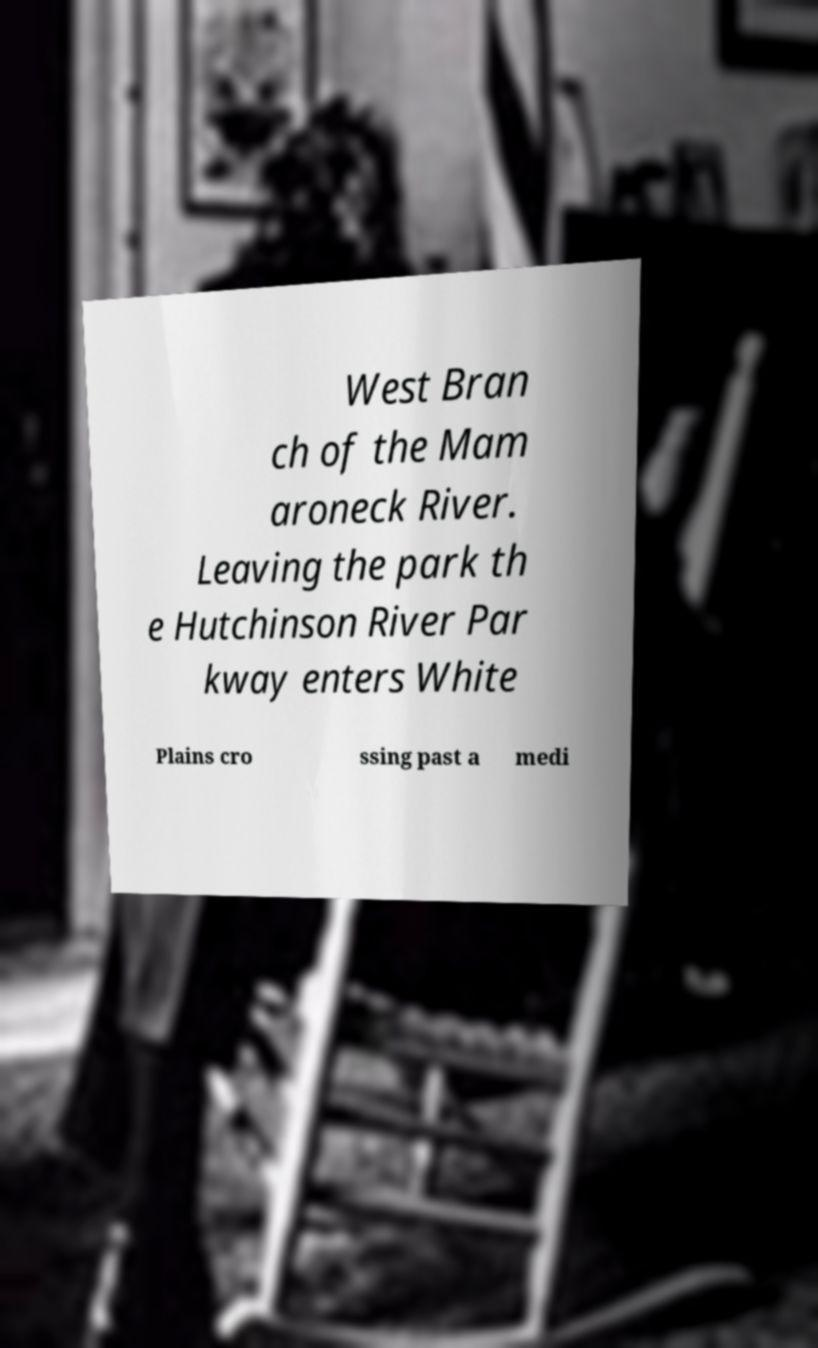Can you read and provide the text displayed in the image?This photo seems to have some interesting text. Can you extract and type it out for me? West Bran ch of the Mam aroneck River. Leaving the park th e Hutchinson River Par kway enters White Plains cro ssing past a medi 